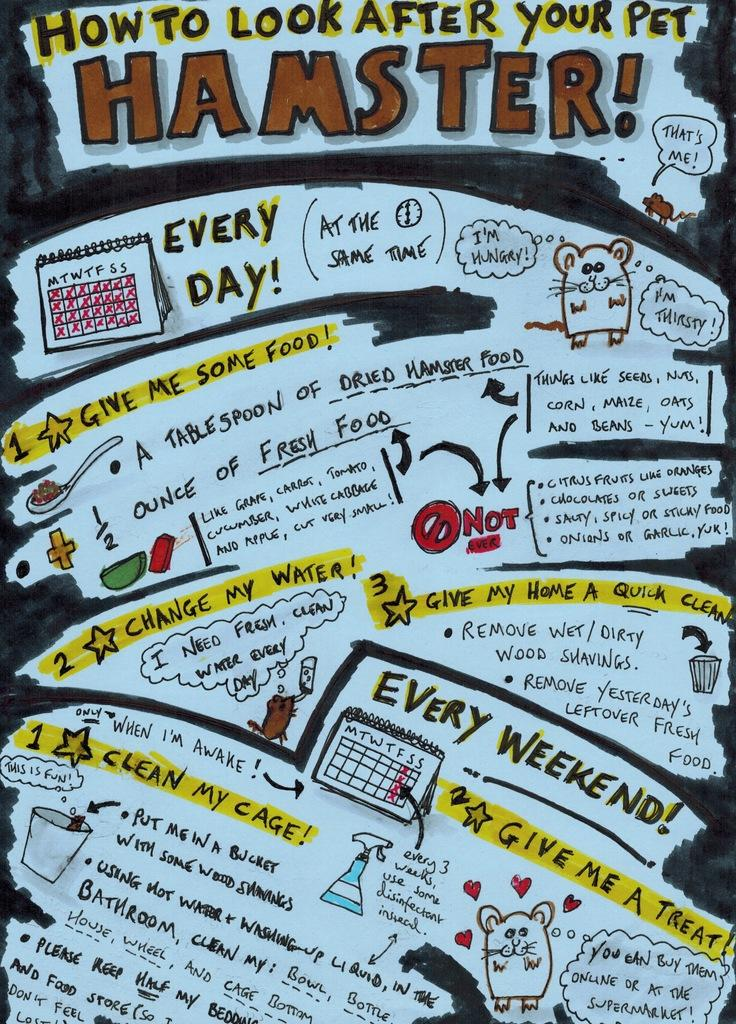What is depicted in the image? There is a drawing of animals in the image. What else can be found in the drawing? There are objects in the drawing. What is the purpose of the calendar in the image? The calendar in the image is likely used for tracking dates or appointments. What type of information is conveyed through the numbers in the image? The numbers in the image may indicate dates, quantities, or other numerical data. What type of information is conveyed through the text in the image? The text in the image may provide labels, descriptions, or instructions related to the drawing or calendar. Where is the secretary located in the image? There is no secretary present in the image. What type of insect can be seen in the jail in the image? There is no insect or jail present in the image. 